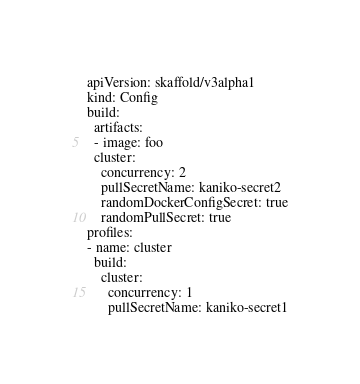Convert code to text. <code><loc_0><loc_0><loc_500><loc_500><_YAML_>apiVersion: skaffold/v3alpha1
kind: Config
build:
  artifacts:
  - image: foo
  cluster:
    concurrency: 2
    pullSecretName: kaniko-secret2
    randomDockerConfigSecret: true
    randomPullSecret: true
profiles:
- name: cluster
  build:
    cluster:
      concurrency: 1
      pullSecretName: kaniko-secret1
</code> 